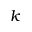<formula> <loc_0><loc_0><loc_500><loc_500>k</formula> 